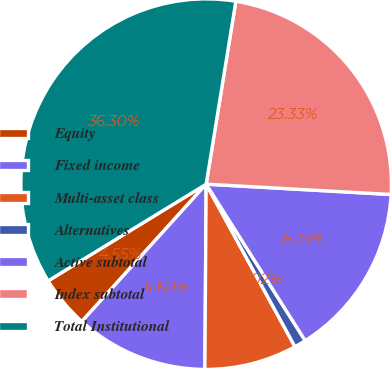Convert chart to OTSL. <chart><loc_0><loc_0><loc_500><loc_500><pie_chart><fcel>Equity<fcel>Fixed income<fcel>Multi-asset class<fcel>Alternatives<fcel>Active subtotal<fcel>Index subtotal<fcel>Total Institutional<nl><fcel>4.55%<fcel>11.6%<fcel>8.07%<fcel>1.02%<fcel>15.13%<fcel>23.33%<fcel>36.3%<nl></chart> 